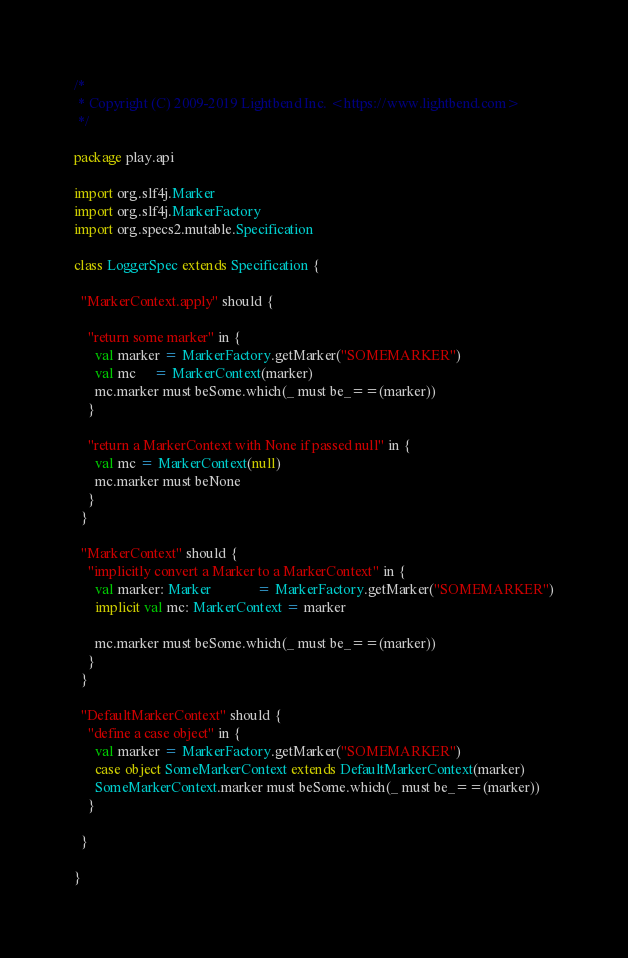<code> <loc_0><loc_0><loc_500><loc_500><_Scala_>/*
 * Copyright (C) 2009-2019 Lightbend Inc. <https://www.lightbend.com>
 */

package play.api

import org.slf4j.Marker
import org.slf4j.MarkerFactory
import org.specs2.mutable.Specification

class LoggerSpec extends Specification {

  "MarkerContext.apply" should {

    "return some marker" in {
      val marker = MarkerFactory.getMarker("SOMEMARKER")
      val mc     = MarkerContext(marker)
      mc.marker must beSome.which(_ must be_==(marker))
    }

    "return a MarkerContext with None if passed null" in {
      val mc = MarkerContext(null)
      mc.marker must beNone
    }
  }

  "MarkerContext" should {
    "implicitly convert a Marker to a MarkerContext" in {
      val marker: Marker             = MarkerFactory.getMarker("SOMEMARKER")
      implicit val mc: MarkerContext = marker

      mc.marker must beSome.which(_ must be_==(marker))
    }
  }

  "DefaultMarkerContext" should {
    "define a case object" in {
      val marker = MarkerFactory.getMarker("SOMEMARKER")
      case object SomeMarkerContext extends DefaultMarkerContext(marker)
      SomeMarkerContext.marker must beSome.which(_ must be_==(marker))
    }

  }

}
</code> 